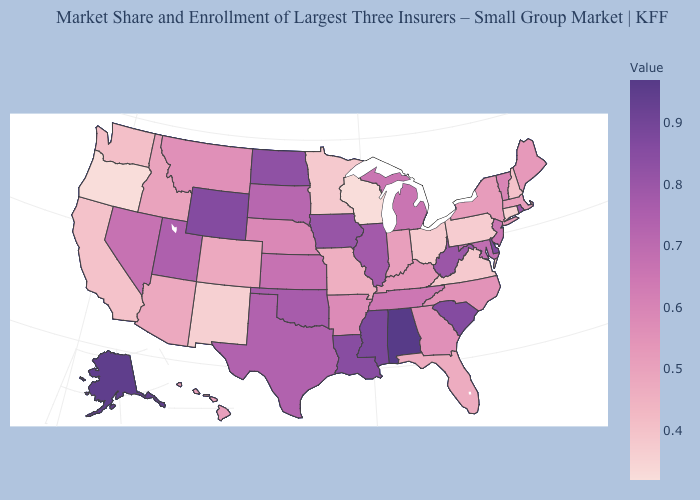Which states have the lowest value in the USA?
Quick response, please. Oregon, Wisconsin. Which states have the lowest value in the USA?
Concise answer only. Oregon, Wisconsin. Among the states that border New York , does New Jersey have the lowest value?
Quick response, please. No. Which states hav the highest value in the Northeast?
Keep it brief. Rhode Island. Among the states that border Massachusetts , does Connecticut have the highest value?
Concise answer only. No. Is the legend a continuous bar?
Concise answer only. Yes. Which states have the lowest value in the West?
Quick response, please. Oregon. Which states have the highest value in the USA?
Write a very short answer. Alabama. 